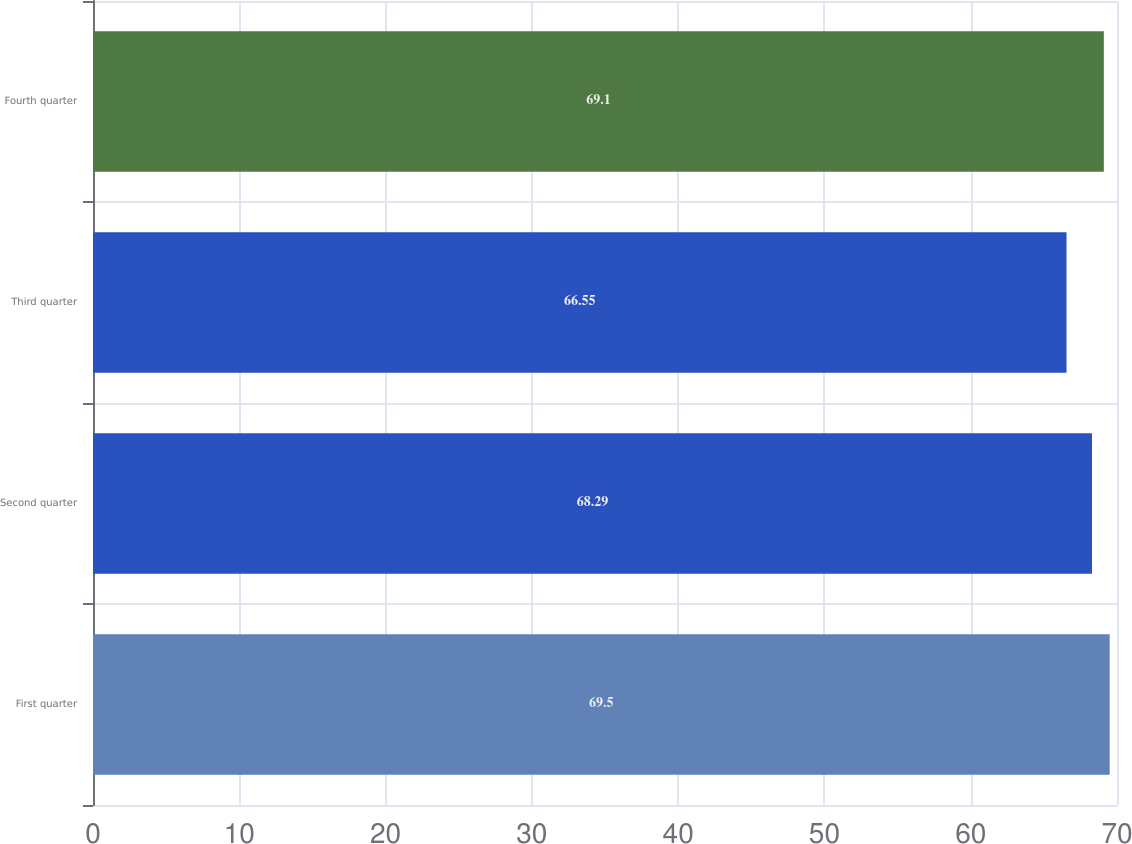Convert chart. <chart><loc_0><loc_0><loc_500><loc_500><bar_chart><fcel>First quarter<fcel>Second quarter<fcel>Third quarter<fcel>Fourth quarter<nl><fcel>69.5<fcel>68.29<fcel>66.55<fcel>69.1<nl></chart> 